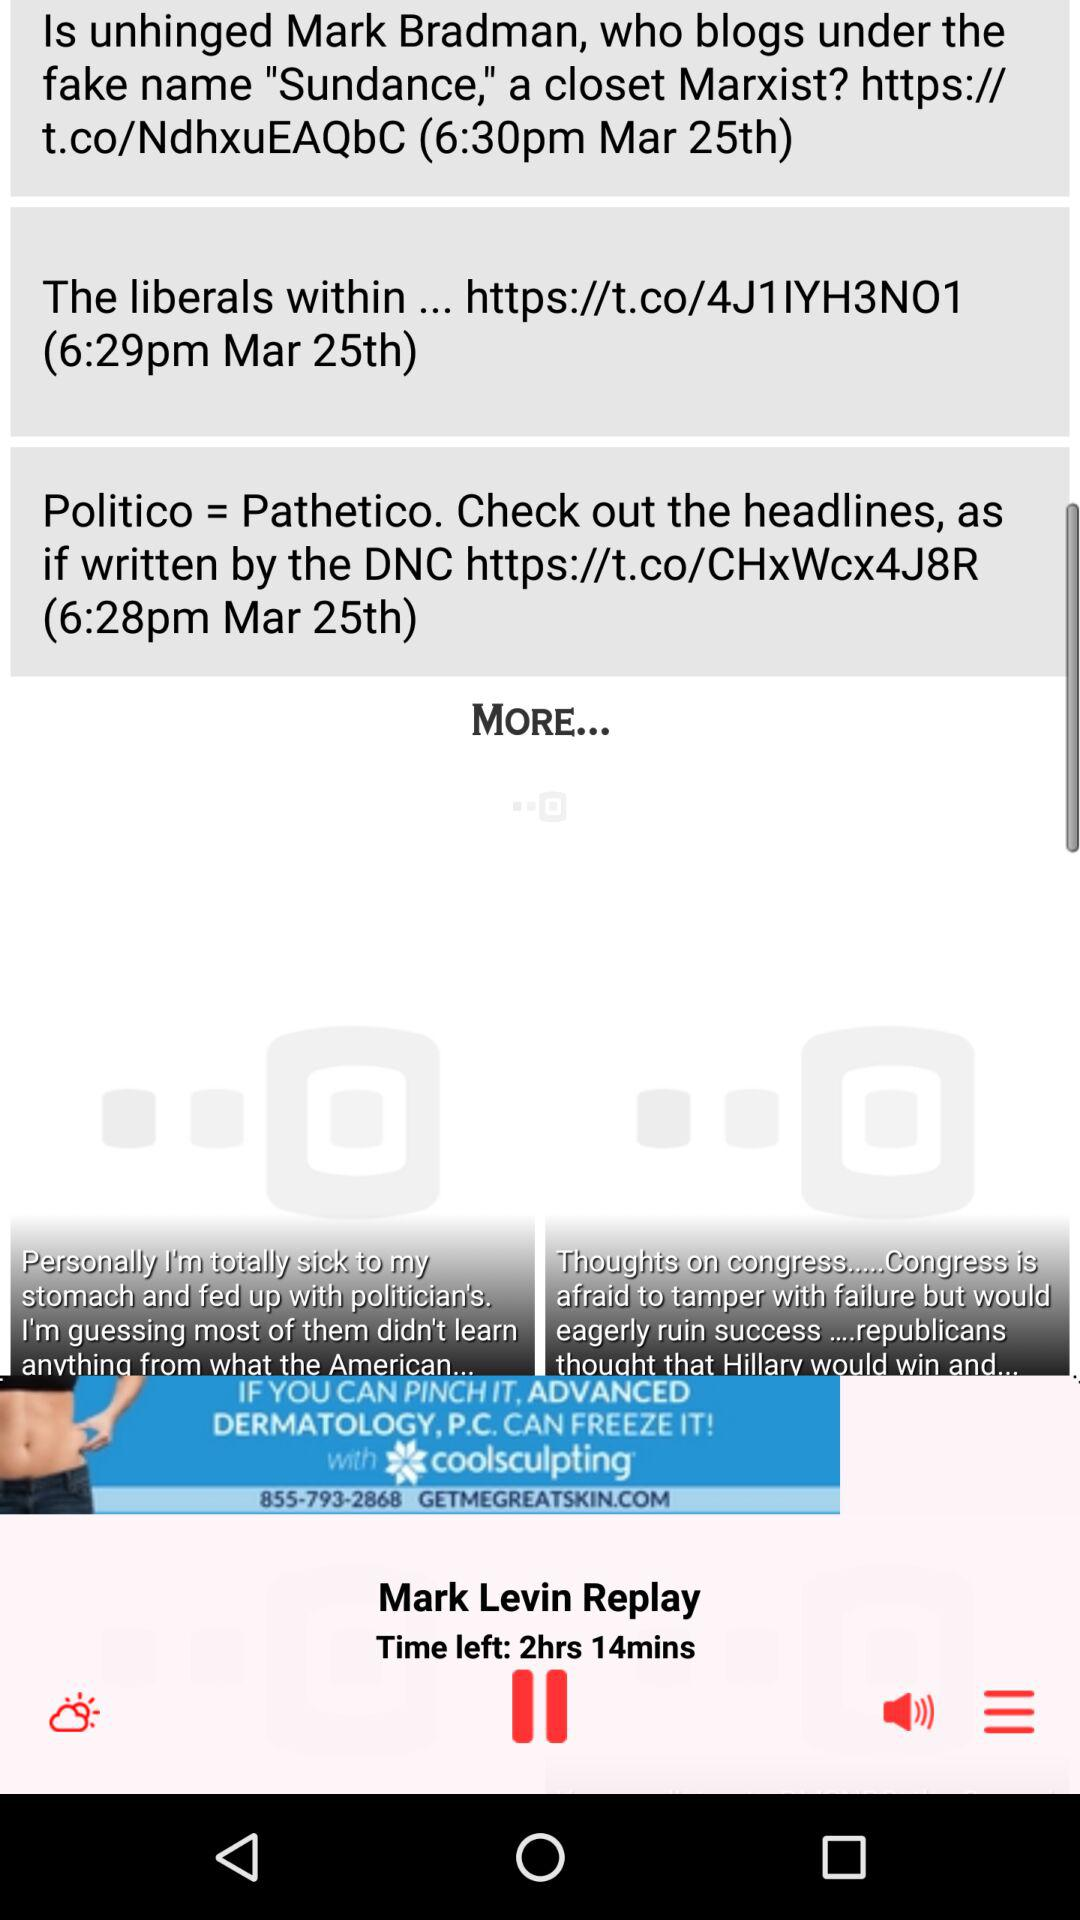On which time the news notification gets?
When the provided information is insufficient, respond with <no answer>. <no answer> 